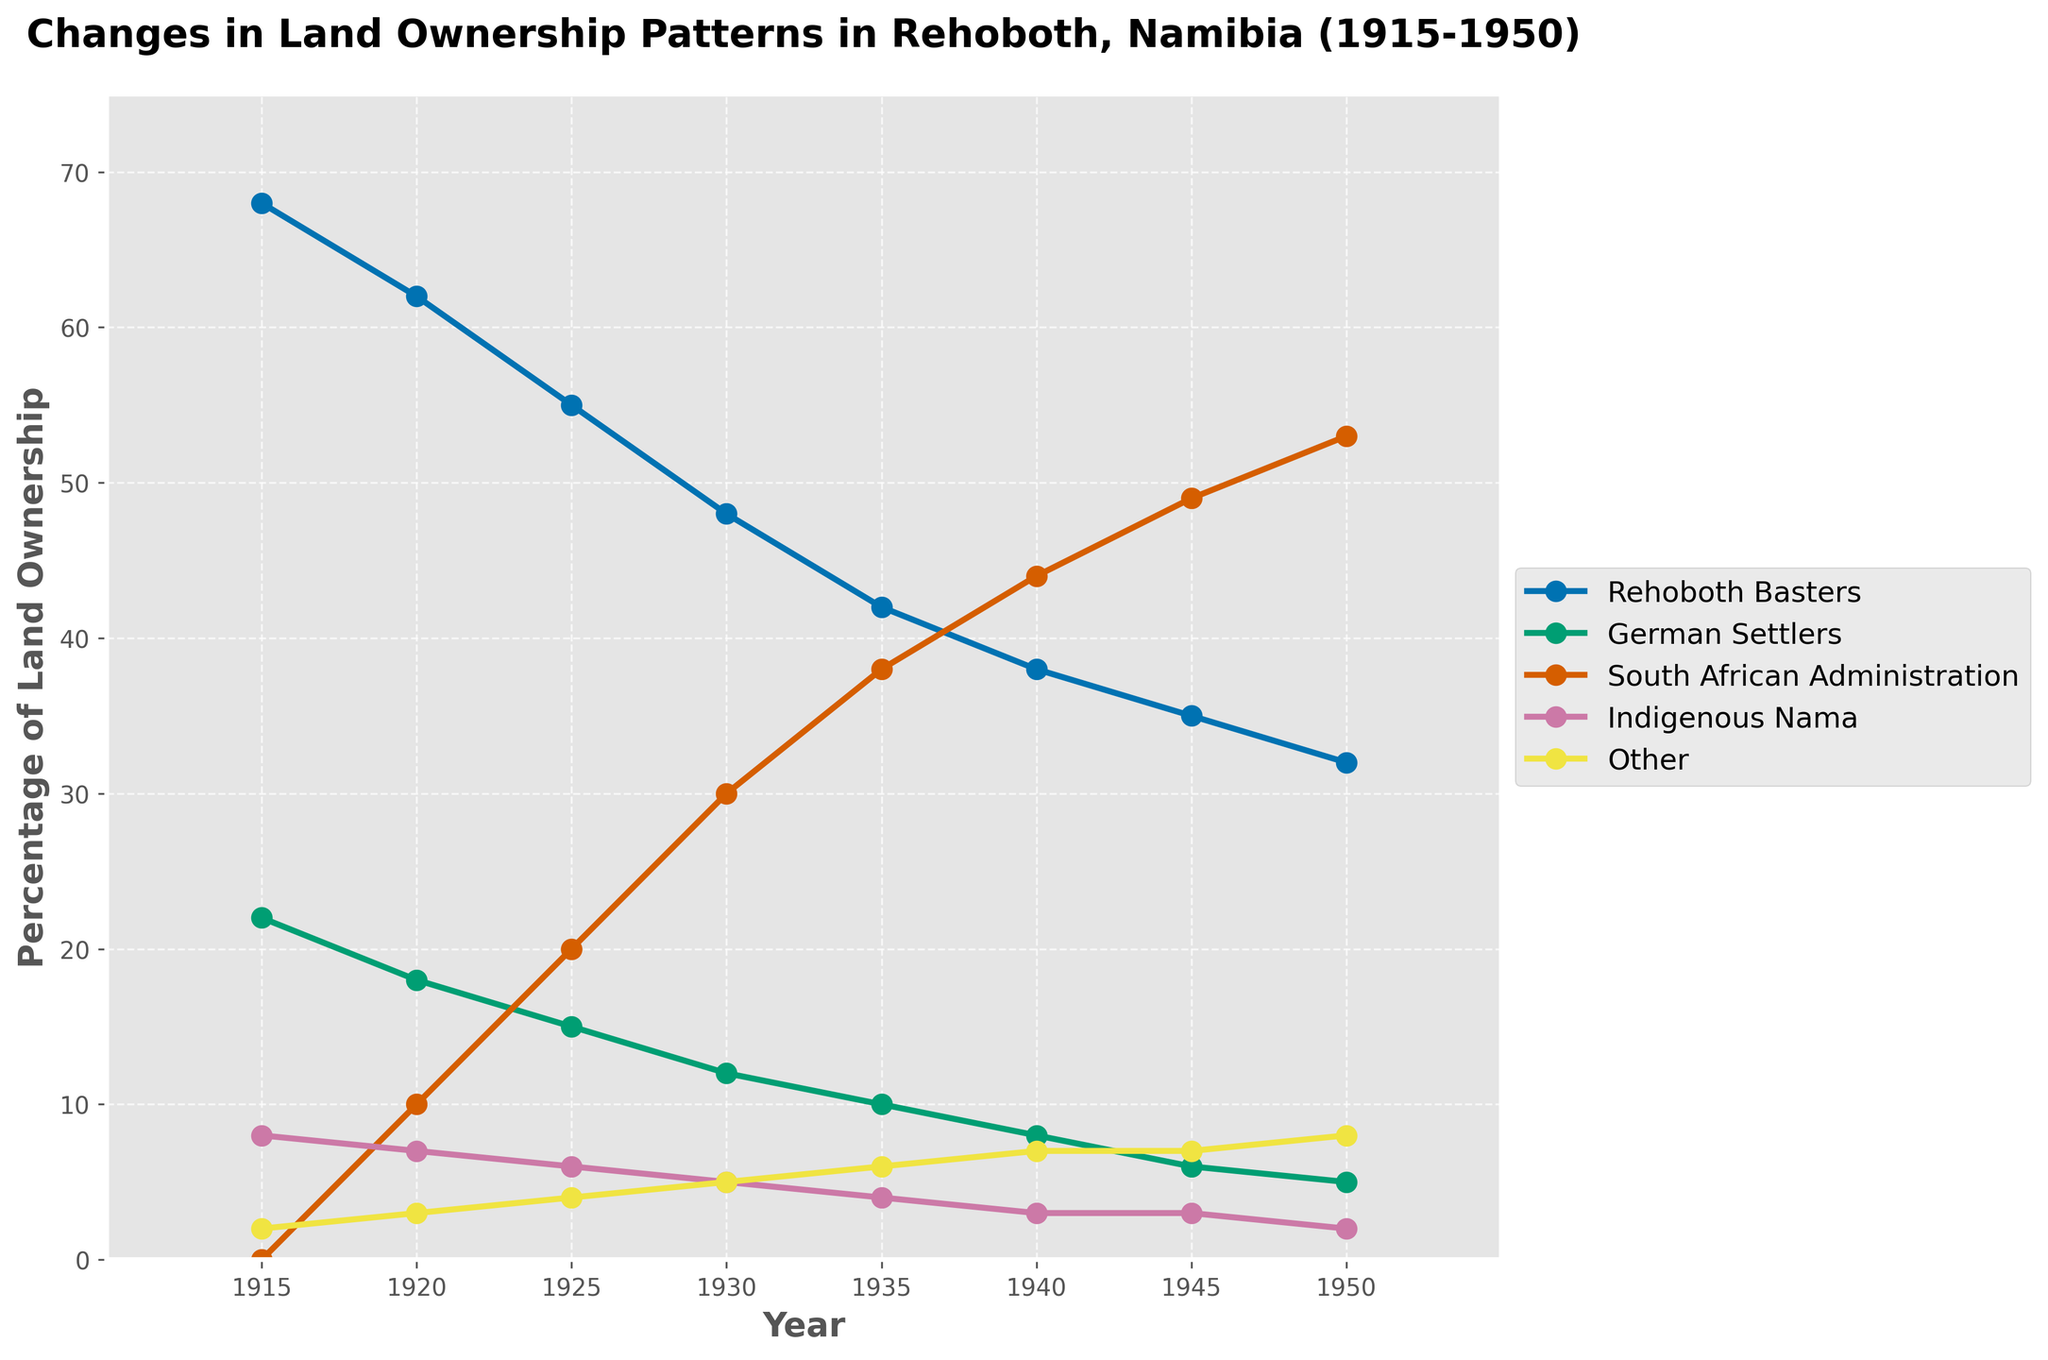What group had the highest percentage of land ownership in 1930? Looking at the graph for 1930, the group with the highest percentage of land ownership is the South African Administration.
Answer: South African Administration How did the percentage of land owned by the Rehoboth Basters change from 1915 to 1950? The percentage was 68% in 1915 and decreased to 32% by 1950. Subtract 32% from 68%.
Answer: Decreased by 36% Which group saw the most significant increase in land ownership between 1925 and 1950? Examining the changes over this period for each group, the South African Administration increased from 20% in 1925 to 53% in 1950, which is the largest increase.
Answer: South African Administration What was the combined percentage of land owned by the German Settlers and Indigenous Nama in 1940? In 1940, German Settlers owned 8% and Indigenous Nama owned 3%. Adding them together, 8% + 3%.
Answer: 11% In which year did the Indigenous Nama hold the highest percentage of land ownership, and what was the percentage? By looking at each data point for Indigenous Nama, they held 8% in 1915, which is their highest value throughout the years.
Answer: 1915, 8% Compare the land ownership between the German Settlers and Other groups in 1920. Which group had a higher percentage, and by how much? The German Settlers had 18% while the Other group had 3% in 1920. Subtract the smaller percentage from the larger.
Answer: German Settlers, by 15% What is the average percentage of land owned by the South African Administration across all recorded years? Add 0 + 10 + 20 + 30 + 38 + 44 + 49 + 53 to get the total for South African Administration, which is 244. There are 8 recorded years, so 244 / 8 = 30.5.
Answer: 30.5% How did the land ownership percentage of the German Settlers change between 1915 and 1945? In 1915, German Settlers owned 22%, which decreased to 6% by 1945. Subtract 6% from 22%.
Answer: Decreased by 16% Between which consecutive years did the percentage of land owned by the Rehoboth Basters decrease the most? By examining year-over-year changes, the largest decrease for the Rehoboth Basters happened between 1930 (48%) and 1935 (42%), which is a 6% decrease.
Answer: 1930-1935 How did land ownership by the Other group change from 1915 to 1950? For the Other group, the percentage was 2% in 1915 and 8% in 1950. Subtract 2% from 8% for the change.
Answer: Increased by 6% 